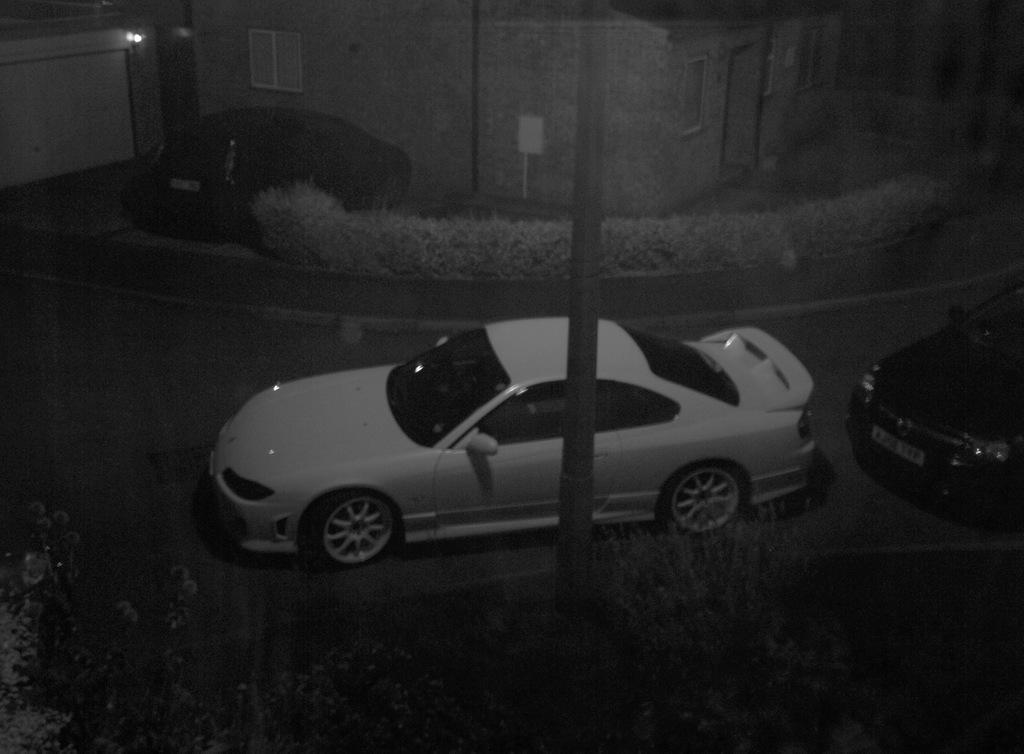Please provide a concise description of this image. In front of the image there are plants. There is a pole. There are cars, bushes, buildings and a board. On the left side of the image there are lights. 